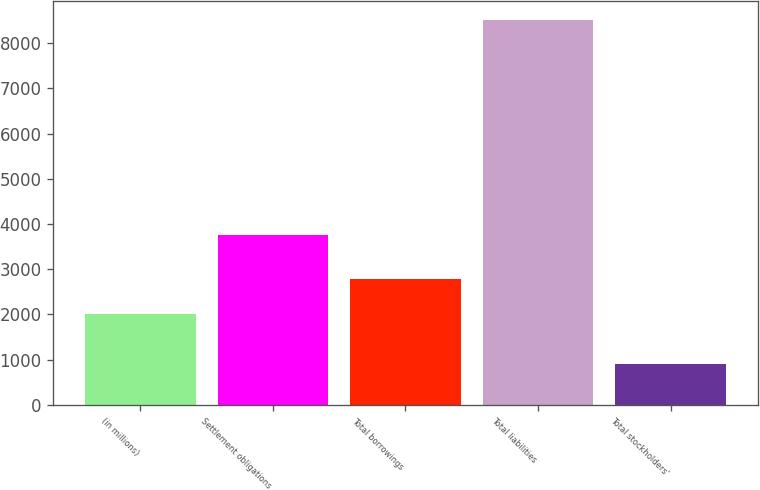<chart> <loc_0><loc_0><loc_500><loc_500><bar_chart><fcel>(in millions)<fcel>Settlement obligations<fcel>Total borrowings<fcel>Total liabilities<fcel>Total stockholders'<nl><fcel>2016<fcel>3749.1<fcel>2786.1<fcel>8517.4<fcel>902.2<nl></chart> 